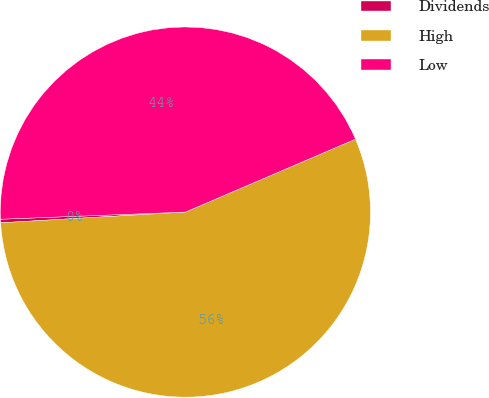Convert chart to OTSL. <chart><loc_0><loc_0><loc_500><loc_500><pie_chart><fcel>Dividends<fcel>High<fcel>Low<nl><fcel>0.31%<fcel>55.53%<fcel>44.17%<nl></chart> 